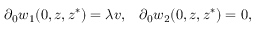Convert formula to latex. <formula><loc_0><loc_0><loc_500><loc_500>\partial _ { 0 } w _ { 1 } ( 0 , z , z ^ { * } ) = \lambda v , \, \partial _ { 0 } w _ { 2 } ( 0 , z , z ^ { * } ) = 0 ,</formula> 